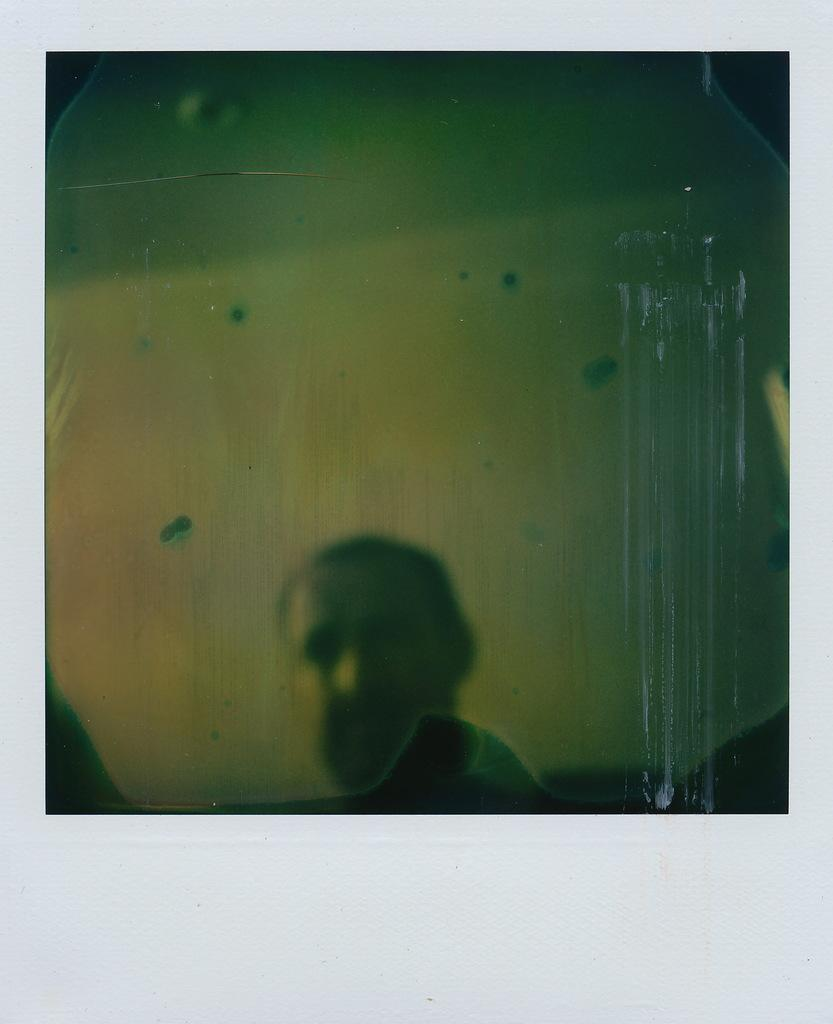What is the main subject of the picture? The main subject of the picture is a person's face. Can you describe any objects or elements above the person's face in the image? Yes, there are other objects above the person's face in the image. What is the condition of the wheel in the image? There is no wheel present in the image; it only features a person's face and objects above it. 